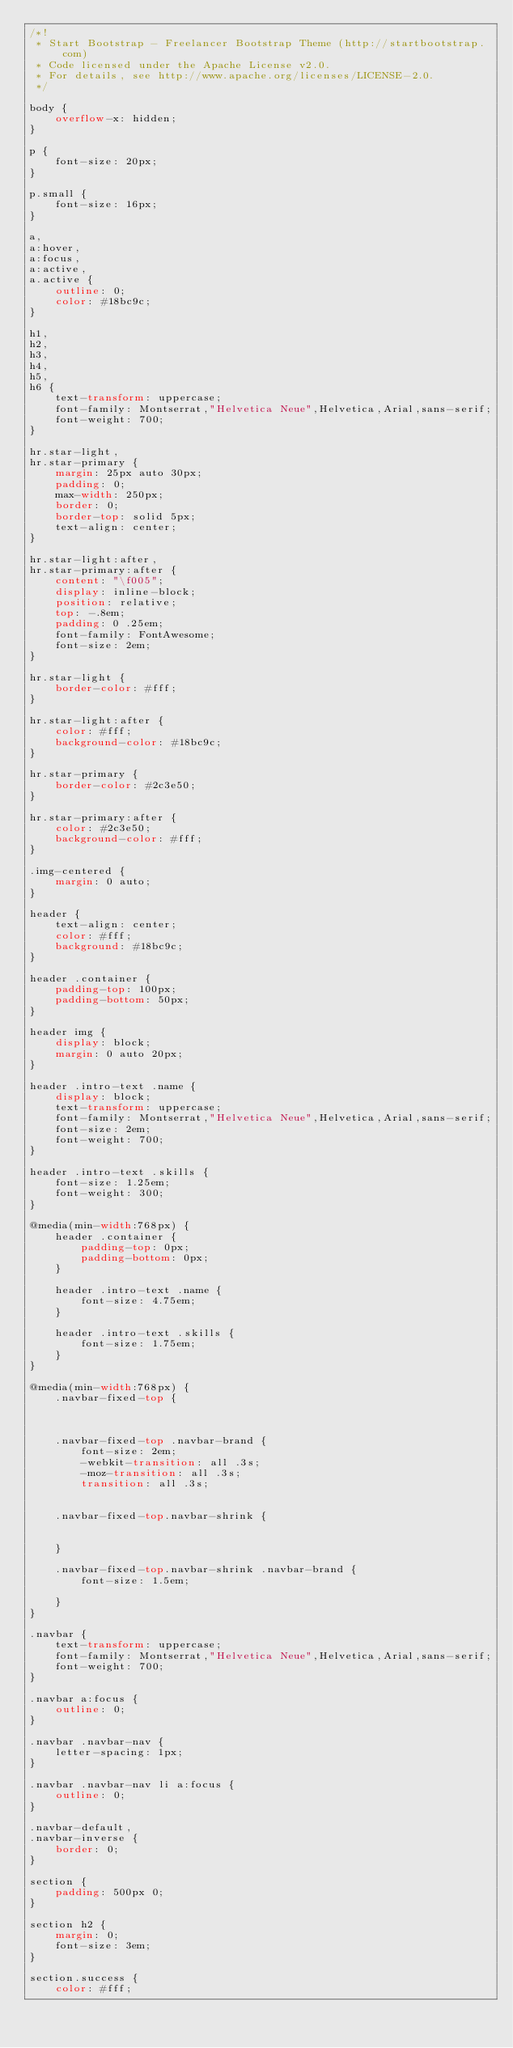<code> <loc_0><loc_0><loc_500><loc_500><_CSS_>/*!
 * Start Bootstrap - Freelancer Bootstrap Theme (http://startbootstrap.com)
 * Code licensed under the Apache License v2.0.
 * For details, see http://www.apache.org/licenses/LICENSE-2.0.
 */

body {
    overflow-x: hidden;
}

p {
    font-size: 20px;
}

p.small {
    font-size: 16px;
}

a,
a:hover,
a:focus,
a:active,
a.active {
    outline: 0;
    color: #18bc9c;
}

h1,
h2,
h3,
h4,
h5,
h6 {
    text-transform: uppercase;
    font-family: Montserrat,"Helvetica Neue",Helvetica,Arial,sans-serif;
    font-weight: 700;
}

hr.star-light,
hr.star-primary {
    margin: 25px auto 30px;
    padding: 0;
    max-width: 250px;
    border: 0;
    border-top: solid 5px;
    text-align: center;
}

hr.star-light:after,
hr.star-primary:after {
    content: "\f005";
    display: inline-block;
    position: relative;
    top: -.8em;
    padding: 0 .25em;
    font-family: FontAwesome;
    font-size: 2em;
}

hr.star-light {
    border-color: #fff;
}

hr.star-light:after {
    color: #fff;
    background-color: #18bc9c;
}

hr.star-primary {
    border-color: #2c3e50;
}

hr.star-primary:after {
    color: #2c3e50;
    background-color: #fff;
}

.img-centered {
    margin: 0 auto;
}

header {
    text-align: center;
    color: #fff;
    background: #18bc9c;
}

header .container {
    padding-top: 100px;
    padding-bottom: 50px;
}

header img {
    display: block;
    margin: 0 auto 20px;
}

header .intro-text .name {
    display: block;
    text-transform: uppercase;
    font-family: Montserrat,"Helvetica Neue",Helvetica,Arial,sans-serif;
    font-size: 2em;
    font-weight: 700;
}

header .intro-text .skills {
    font-size: 1.25em;
    font-weight: 300;
}

@media(min-width:768px) {
    header .container {
        padding-top: 0px;
        padding-bottom: 0px;
    }

    header .intro-text .name {
        font-size: 4.75em;
    }

    header .intro-text .skills {
        font-size: 1.75em;
    }
}

@media(min-width:768px) {
    .navbar-fixed-top {

       

    .navbar-fixed-top .navbar-brand {
        font-size: 2em;
        -webkit-transition: all .3s;
        -moz-transition: all .3s;
        transition: all .3s;
        

    .navbar-fixed-top.navbar-shrink {
        
        
    }

    .navbar-fixed-top.navbar-shrink .navbar-brand {
        font-size: 1.5em;
        
    }
}

.navbar {
    text-transform: uppercase;
    font-family: Montserrat,"Helvetica Neue",Helvetica,Arial,sans-serif;
    font-weight: 700;
}

.navbar a:focus {
    outline: 0;
}

.navbar .navbar-nav {
    letter-spacing: 1px;
}

.navbar .navbar-nav li a:focus {
    outline: 0;
}

.navbar-default,
.navbar-inverse {
    border: 0;
}

section {
    padding: 500px 0;
}

section h2 {
    margin: 0;
    font-size: 3em;
}

section.success {
    color: #fff;</code> 